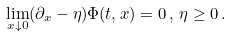Convert formula to latex. <formula><loc_0><loc_0><loc_500><loc_500>\lim _ { x \downarrow 0 } ( \partial _ { x } - \eta ) \Phi ( t , x ) = 0 \, , \, \eta \geq 0 \, .</formula> 